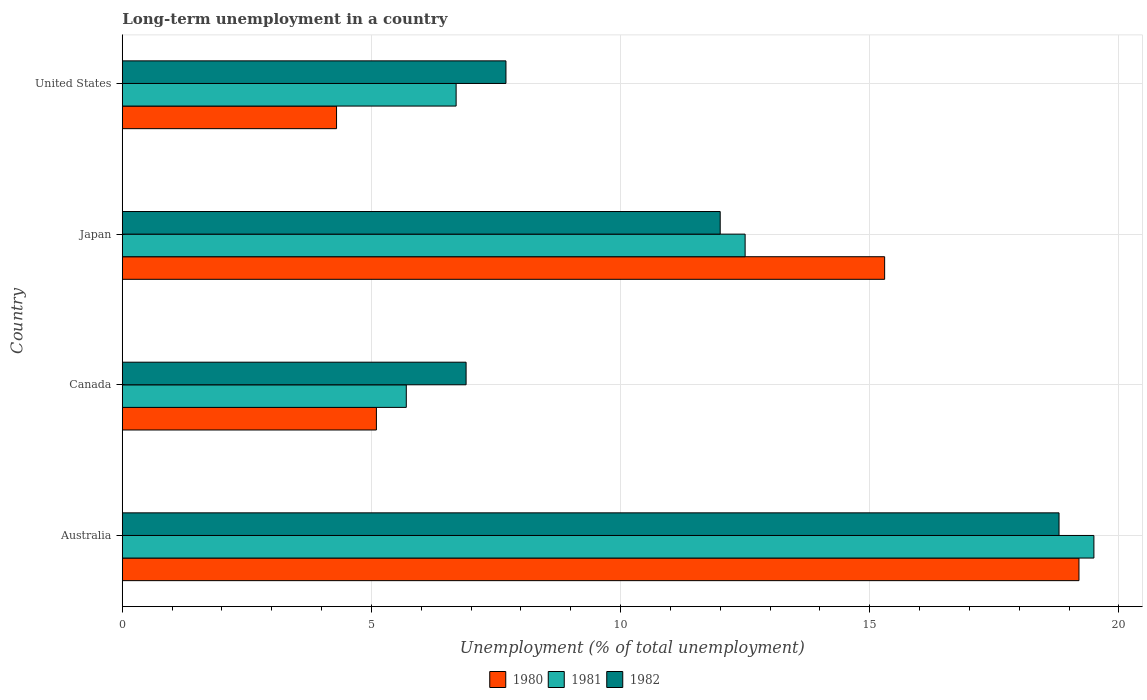How many different coloured bars are there?
Provide a short and direct response. 3. Are the number of bars per tick equal to the number of legend labels?
Your answer should be very brief. Yes. Are the number of bars on each tick of the Y-axis equal?
Ensure brevity in your answer.  Yes. How many bars are there on the 1st tick from the top?
Your answer should be compact. 3. What is the percentage of long-term unemployed population in 1980 in Canada?
Offer a very short reply. 5.1. Across all countries, what is the maximum percentage of long-term unemployed population in 1982?
Ensure brevity in your answer.  18.8. Across all countries, what is the minimum percentage of long-term unemployed population in 1981?
Offer a terse response. 5.7. In which country was the percentage of long-term unemployed population in 1980 maximum?
Give a very brief answer. Australia. What is the total percentage of long-term unemployed population in 1982 in the graph?
Offer a terse response. 45.4. What is the difference between the percentage of long-term unemployed population in 1981 in Australia and that in Canada?
Your answer should be very brief. 13.8. What is the difference between the percentage of long-term unemployed population in 1980 in Japan and the percentage of long-term unemployed population in 1982 in Australia?
Make the answer very short. -3.5. What is the average percentage of long-term unemployed population in 1982 per country?
Keep it short and to the point. 11.35. What is the difference between the percentage of long-term unemployed population in 1980 and percentage of long-term unemployed population in 1982 in Australia?
Offer a very short reply. 0.4. In how many countries, is the percentage of long-term unemployed population in 1980 greater than 19 %?
Make the answer very short. 1. What is the ratio of the percentage of long-term unemployed population in 1982 in Japan to that in United States?
Provide a succinct answer. 1.56. Is the percentage of long-term unemployed population in 1980 in Japan less than that in United States?
Offer a terse response. No. What is the difference between the highest and the second highest percentage of long-term unemployed population in 1982?
Make the answer very short. 6.8. What is the difference between the highest and the lowest percentage of long-term unemployed population in 1980?
Your answer should be compact. 14.9. In how many countries, is the percentage of long-term unemployed population in 1981 greater than the average percentage of long-term unemployed population in 1981 taken over all countries?
Your answer should be compact. 2. What does the 2nd bar from the top in Australia represents?
Your response must be concise. 1981. How many bars are there?
Ensure brevity in your answer.  12. How many countries are there in the graph?
Offer a terse response. 4. What is the difference between two consecutive major ticks on the X-axis?
Ensure brevity in your answer.  5. Are the values on the major ticks of X-axis written in scientific E-notation?
Offer a terse response. No. Does the graph contain any zero values?
Give a very brief answer. No. How many legend labels are there?
Keep it short and to the point. 3. How are the legend labels stacked?
Make the answer very short. Horizontal. What is the title of the graph?
Provide a succinct answer. Long-term unemployment in a country. Does "1961" appear as one of the legend labels in the graph?
Ensure brevity in your answer.  No. What is the label or title of the X-axis?
Make the answer very short. Unemployment (% of total unemployment). What is the label or title of the Y-axis?
Ensure brevity in your answer.  Country. What is the Unemployment (% of total unemployment) in 1980 in Australia?
Your answer should be compact. 19.2. What is the Unemployment (% of total unemployment) of 1981 in Australia?
Your response must be concise. 19.5. What is the Unemployment (% of total unemployment) in 1982 in Australia?
Provide a short and direct response. 18.8. What is the Unemployment (% of total unemployment) in 1980 in Canada?
Offer a very short reply. 5.1. What is the Unemployment (% of total unemployment) of 1981 in Canada?
Keep it short and to the point. 5.7. What is the Unemployment (% of total unemployment) of 1982 in Canada?
Keep it short and to the point. 6.9. What is the Unemployment (% of total unemployment) in 1980 in Japan?
Your response must be concise. 15.3. What is the Unemployment (% of total unemployment) in 1980 in United States?
Your answer should be compact. 4.3. What is the Unemployment (% of total unemployment) in 1981 in United States?
Offer a terse response. 6.7. What is the Unemployment (% of total unemployment) in 1982 in United States?
Provide a succinct answer. 7.7. Across all countries, what is the maximum Unemployment (% of total unemployment) of 1980?
Ensure brevity in your answer.  19.2. Across all countries, what is the maximum Unemployment (% of total unemployment) in 1982?
Offer a very short reply. 18.8. Across all countries, what is the minimum Unemployment (% of total unemployment) of 1980?
Your answer should be compact. 4.3. Across all countries, what is the minimum Unemployment (% of total unemployment) of 1981?
Your answer should be very brief. 5.7. Across all countries, what is the minimum Unemployment (% of total unemployment) in 1982?
Give a very brief answer. 6.9. What is the total Unemployment (% of total unemployment) of 1980 in the graph?
Offer a terse response. 43.9. What is the total Unemployment (% of total unemployment) in 1981 in the graph?
Your answer should be compact. 44.4. What is the total Unemployment (% of total unemployment) in 1982 in the graph?
Offer a very short reply. 45.4. What is the difference between the Unemployment (% of total unemployment) of 1982 in Australia and that in Canada?
Your response must be concise. 11.9. What is the difference between the Unemployment (% of total unemployment) of 1980 in Australia and that in Japan?
Offer a very short reply. 3.9. What is the difference between the Unemployment (% of total unemployment) in 1980 in Australia and that in United States?
Ensure brevity in your answer.  14.9. What is the difference between the Unemployment (% of total unemployment) in 1982 in Australia and that in United States?
Your response must be concise. 11.1. What is the difference between the Unemployment (% of total unemployment) of 1981 in Canada and that in Japan?
Your answer should be compact. -6.8. What is the difference between the Unemployment (% of total unemployment) in 1980 in Canada and that in United States?
Ensure brevity in your answer.  0.8. What is the difference between the Unemployment (% of total unemployment) in 1981 in Canada and that in United States?
Provide a short and direct response. -1. What is the difference between the Unemployment (% of total unemployment) in 1980 in Japan and that in United States?
Give a very brief answer. 11. What is the difference between the Unemployment (% of total unemployment) of 1981 in Japan and that in United States?
Keep it short and to the point. 5.8. What is the difference between the Unemployment (% of total unemployment) in 1982 in Japan and that in United States?
Keep it short and to the point. 4.3. What is the difference between the Unemployment (% of total unemployment) in 1981 in Australia and the Unemployment (% of total unemployment) in 1982 in Canada?
Your answer should be compact. 12.6. What is the difference between the Unemployment (% of total unemployment) of 1980 in Australia and the Unemployment (% of total unemployment) of 1981 in Japan?
Offer a very short reply. 6.7. What is the difference between the Unemployment (% of total unemployment) of 1980 in Australia and the Unemployment (% of total unemployment) of 1982 in Japan?
Offer a very short reply. 7.2. What is the difference between the Unemployment (% of total unemployment) of 1981 in Australia and the Unemployment (% of total unemployment) of 1982 in Japan?
Keep it short and to the point. 7.5. What is the difference between the Unemployment (% of total unemployment) in 1980 in Australia and the Unemployment (% of total unemployment) in 1981 in United States?
Your answer should be compact. 12.5. What is the difference between the Unemployment (% of total unemployment) of 1981 in Australia and the Unemployment (% of total unemployment) of 1982 in United States?
Ensure brevity in your answer.  11.8. What is the difference between the Unemployment (% of total unemployment) in 1980 in Canada and the Unemployment (% of total unemployment) in 1981 in Japan?
Ensure brevity in your answer.  -7.4. What is the difference between the Unemployment (% of total unemployment) of 1980 in Canada and the Unemployment (% of total unemployment) of 1982 in Japan?
Give a very brief answer. -6.9. What is the difference between the Unemployment (% of total unemployment) of 1981 in Canada and the Unemployment (% of total unemployment) of 1982 in Japan?
Keep it short and to the point. -6.3. What is the difference between the Unemployment (% of total unemployment) in 1980 in Canada and the Unemployment (% of total unemployment) in 1981 in United States?
Provide a succinct answer. -1.6. What is the difference between the Unemployment (% of total unemployment) in 1980 in Canada and the Unemployment (% of total unemployment) in 1982 in United States?
Ensure brevity in your answer.  -2.6. What is the difference between the Unemployment (% of total unemployment) in 1981 in Canada and the Unemployment (% of total unemployment) in 1982 in United States?
Your response must be concise. -2. What is the difference between the Unemployment (% of total unemployment) in 1980 in Japan and the Unemployment (% of total unemployment) in 1981 in United States?
Give a very brief answer. 8.6. What is the difference between the Unemployment (% of total unemployment) in 1981 in Japan and the Unemployment (% of total unemployment) in 1982 in United States?
Provide a short and direct response. 4.8. What is the average Unemployment (% of total unemployment) in 1980 per country?
Ensure brevity in your answer.  10.97. What is the average Unemployment (% of total unemployment) in 1981 per country?
Provide a succinct answer. 11.1. What is the average Unemployment (% of total unemployment) of 1982 per country?
Offer a very short reply. 11.35. What is the difference between the Unemployment (% of total unemployment) in 1980 and Unemployment (% of total unemployment) in 1981 in Australia?
Make the answer very short. -0.3. What is the difference between the Unemployment (% of total unemployment) in 1980 and Unemployment (% of total unemployment) in 1982 in Australia?
Make the answer very short. 0.4. What is the difference between the Unemployment (% of total unemployment) in 1981 and Unemployment (% of total unemployment) in 1982 in Australia?
Offer a terse response. 0.7. What is the difference between the Unemployment (% of total unemployment) in 1980 and Unemployment (% of total unemployment) in 1981 in Canada?
Ensure brevity in your answer.  -0.6. What is the difference between the Unemployment (% of total unemployment) of 1980 and Unemployment (% of total unemployment) of 1982 in Canada?
Your answer should be very brief. -1.8. What is the difference between the Unemployment (% of total unemployment) in 1981 and Unemployment (% of total unemployment) in 1982 in Canada?
Your answer should be compact. -1.2. What is the difference between the Unemployment (% of total unemployment) of 1980 and Unemployment (% of total unemployment) of 1981 in Japan?
Your answer should be compact. 2.8. What is the difference between the Unemployment (% of total unemployment) of 1980 and Unemployment (% of total unemployment) of 1982 in Japan?
Ensure brevity in your answer.  3.3. What is the difference between the Unemployment (% of total unemployment) of 1980 and Unemployment (% of total unemployment) of 1982 in United States?
Your response must be concise. -3.4. What is the difference between the Unemployment (% of total unemployment) in 1981 and Unemployment (% of total unemployment) in 1982 in United States?
Your answer should be compact. -1. What is the ratio of the Unemployment (% of total unemployment) in 1980 in Australia to that in Canada?
Provide a succinct answer. 3.76. What is the ratio of the Unemployment (% of total unemployment) in 1981 in Australia to that in Canada?
Make the answer very short. 3.42. What is the ratio of the Unemployment (% of total unemployment) of 1982 in Australia to that in Canada?
Your answer should be compact. 2.72. What is the ratio of the Unemployment (% of total unemployment) in 1980 in Australia to that in Japan?
Keep it short and to the point. 1.25. What is the ratio of the Unemployment (% of total unemployment) in 1981 in Australia to that in Japan?
Provide a succinct answer. 1.56. What is the ratio of the Unemployment (% of total unemployment) in 1982 in Australia to that in Japan?
Keep it short and to the point. 1.57. What is the ratio of the Unemployment (% of total unemployment) of 1980 in Australia to that in United States?
Ensure brevity in your answer.  4.47. What is the ratio of the Unemployment (% of total unemployment) of 1981 in Australia to that in United States?
Make the answer very short. 2.91. What is the ratio of the Unemployment (% of total unemployment) of 1982 in Australia to that in United States?
Your answer should be compact. 2.44. What is the ratio of the Unemployment (% of total unemployment) of 1980 in Canada to that in Japan?
Offer a very short reply. 0.33. What is the ratio of the Unemployment (% of total unemployment) in 1981 in Canada to that in Japan?
Give a very brief answer. 0.46. What is the ratio of the Unemployment (% of total unemployment) in 1982 in Canada to that in Japan?
Offer a terse response. 0.57. What is the ratio of the Unemployment (% of total unemployment) of 1980 in Canada to that in United States?
Your answer should be compact. 1.19. What is the ratio of the Unemployment (% of total unemployment) in 1981 in Canada to that in United States?
Provide a short and direct response. 0.85. What is the ratio of the Unemployment (% of total unemployment) in 1982 in Canada to that in United States?
Ensure brevity in your answer.  0.9. What is the ratio of the Unemployment (% of total unemployment) of 1980 in Japan to that in United States?
Your response must be concise. 3.56. What is the ratio of the Unemployment (% of total unemployment) of 1981 in Japan to that in United States?
Your answer should be compact. 1.87. What is the ratio of the Unemployment (% of total unemployment) of 1982 in Japan to that in United States?
Offer a terse response. 1.56. What is the difference between the highest and the second highest Unemployment (% of total unemployment) of 1980?
Offer a very short reply. 3.9. What is the difference between the highest and the lowest Unemployment (% of total unemployment) of 1980?
Make the answer very short. 14.9. 